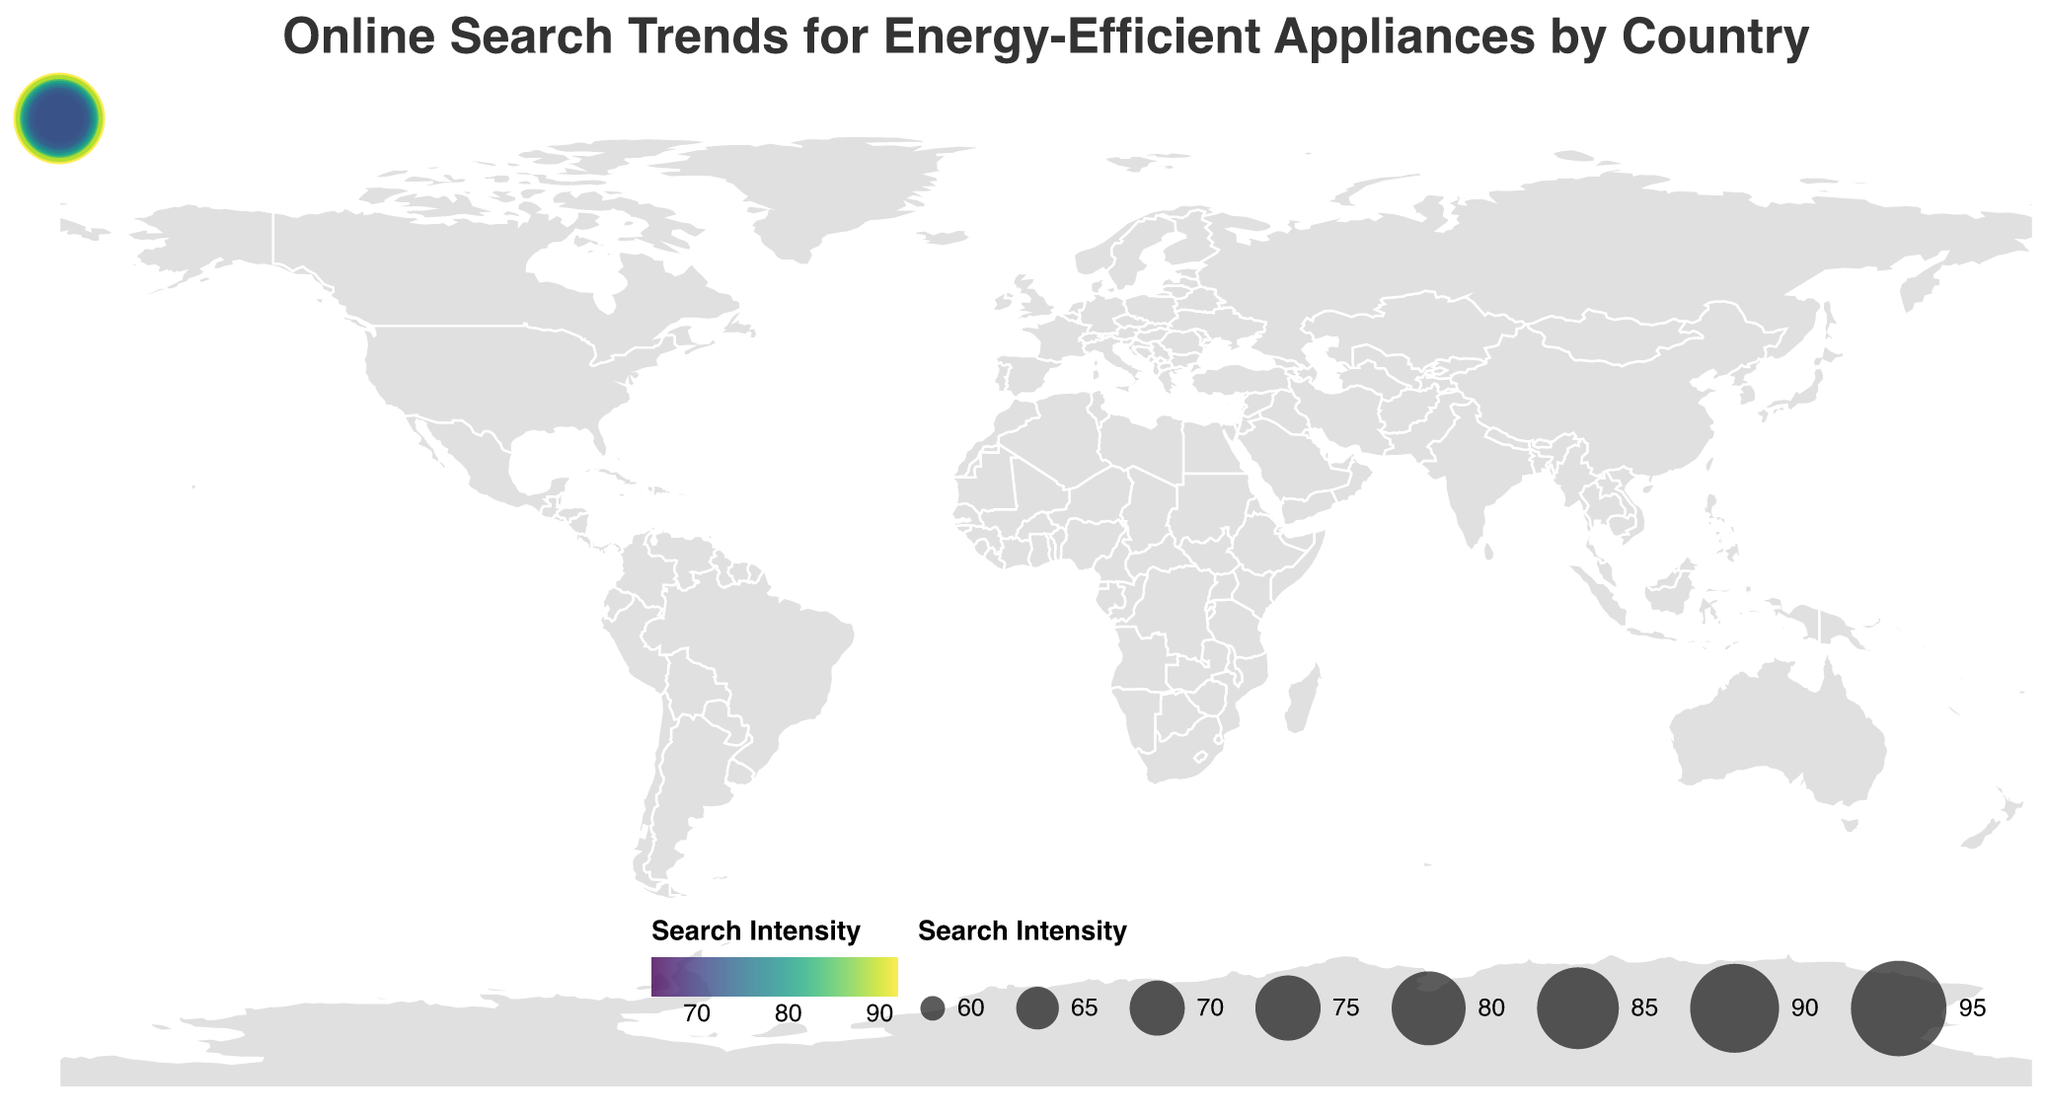What is the title of the figure? The title of the figure can be found at the top, typically in larger and bold font that stands out. In this case, the title reads "Online Search Trends for Energy-Efficient Appliances by Country".
Answer: Online Search Trends for Energy-Efficient Appliances by Country Which country has the highest search intensity for energy-efficient appliances? To determine the country with the highest search intensity, look for the value that is the largest among the data points. Here, Japan has the highest search intensity with a value of 92.
Answer: Japan How many countries have a search intensity of 80 or higher? To answer this, identify all instances where the search intensity is 80 or above. The countries are United States (85), Japan (92), Germany (88), United Kingdom (79), South Korea (89), Sweden (83), and Netherlands (81), but excluding United Kingdom because it's not 80 or higher.
Answer: 7 Which country has the lowest search intensity? Look for the smallest value under the search intensity column to find the minimum search intensity. Spain has the lowest search intensity at 65.
Answer: Spain What is the average search intensity among all countries listed? Sum all the search intensity values and divide by the number of countries. Total search intensity = 1462, and there are 20 countries. So, the average is 1462/20 = 73.1
Answer: 73.1 Compare the search intensity between Canada and Australia. Which country has a higher search intensity? Canada (76) vs. Australia (72). Canada has a higher search intensity than Australia.
Answer: Canada Are there any countries from the provided data with a search intensity between 70 and 75 inclusive? The countries with search intensities within this range are France (70), Belgium (71), Singapore (73), and Switzerland (75).
Answer: 4 What is the total search intensity of countries with a search intensity greater than 85? Sum the search intensities of all countries where the search intensity is greater than 85. These countries are Japan (92), Germany (88), South Korea (89). Total is 92 + 88 + 89 = 269.
Answer: 269 Which European country has the highest search intensity? To find the highest search intensity among European countries, look for the maximum search value among Germany (88), United Kingdom (79), France (70), Sweden (83), Netherlands (81), Italy (68), Spain (65), Denmark (80), Norway (78), Finland (77), Switzerland (75), Belgium (71), Austria (69). Germany has the highest at 88.
Answer: Germany What is the difference in search intensity between the country with the highest and the country with the lowest search intensity? Identify the highest (Japan, 92) and lowest (Spain, 65) search intensities, then calculate the difference: 92 - 65 = 27.
Answer: 27 